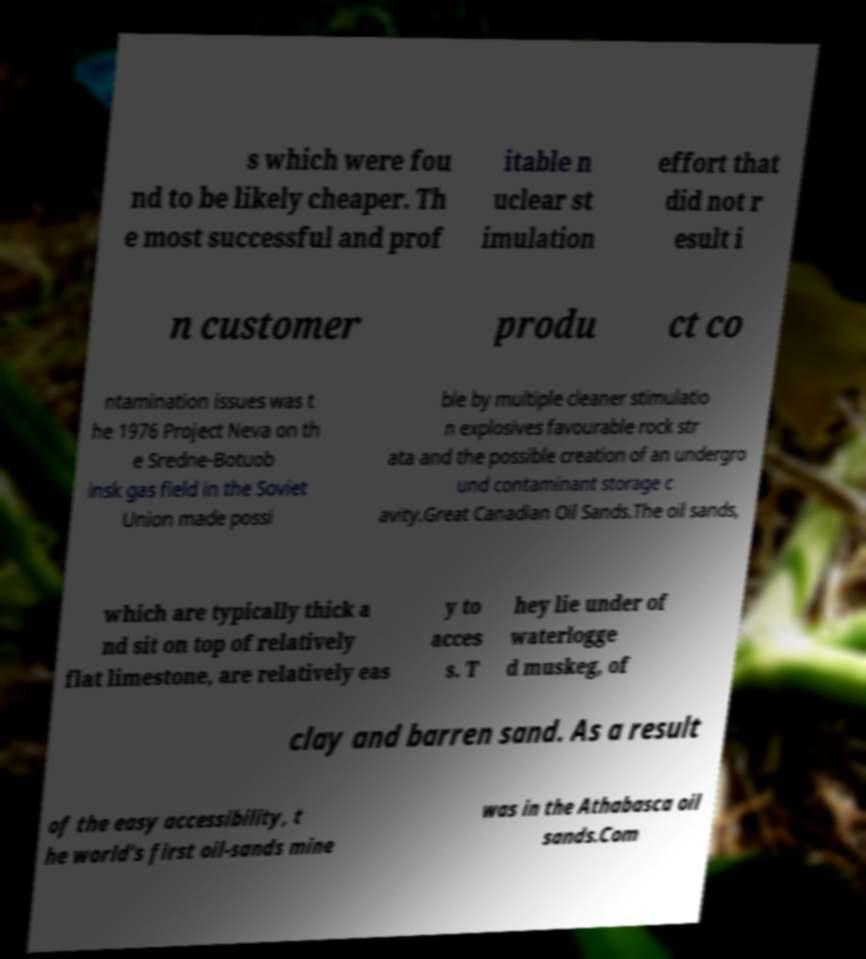Can you read and provide the text displayed in the image?This photo seems to have some interesting text. Can you extract and type it out for me? s which were fou nd to be likely cheaper. Th e most successful and prof itable n uclear st imulation effort that did not r esult i n customer produ ct co ntamination issues was t he 1976 Project Neva on th e Sredne-Botuob insk gas field in the Soviet Union made possi ble by multiple cleaner stimulatio n explosives favourable rock str ata and the possible creation of an undergro und contaminant storage c avity.Great Canadian Oil Sands.The oil sands, which are typically thick a nd sit on top of relatively flat limestone, are relatively eas y to acces s. T hey lie under of waterlogge d muskeg, of clay and barren sand. As a result of the easy accessibility, t he world's first oil-sands mine was in the Athabasca oil sands.Com 